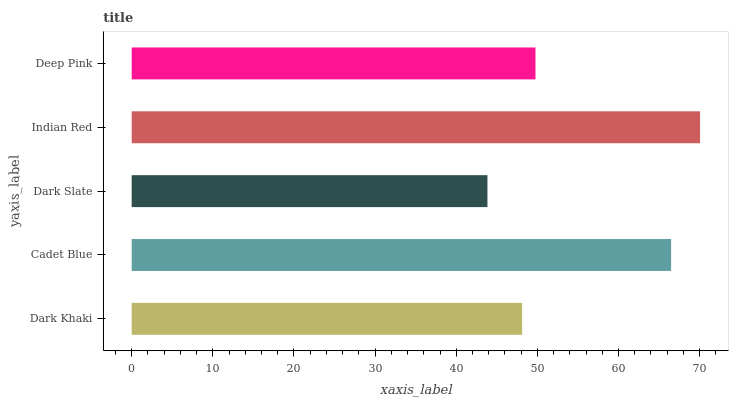Is Dark Slate the minimum?
Answer yes or no. Yes. Is Indian Red the maximum?
Answer yes or no. Yes. Is Cadet Blue the minimum?
Answer yes or no. No. Is Cadet Blue the maximum?
Answer yes or no. No. Is Cadet Blue greater than Dark Khaki?
Answer yes or no. Yes. Is Dark Khaki less than Cadet Blue?
Answer yes or no. Yes. Is Dark Khaki greater than Cadet Blue?
Answer yes or no. No. Is Cadet Blue less than Dark Khaki?
Answer yes or no. No. Is Deep Pink the high median?
Answer yes or no. Yes. Is Deep Pink the low median?
Answer yes or no. Yes. Is Dark Khaki the high median?
Answer yes or no. No. Is Indian Red the low median?
Answer yes or no. No. 